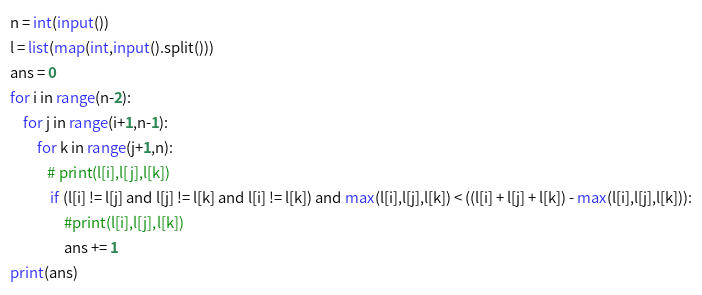<code> <loc_0><loc_0><loc_500><loc_500><_Python_>n = int(input())
l = list(map(int,input().split()))
ans = 0
for i in range(n-2):
    for j in range(i+1,n-1):
        for k in range(j+1,n):
           # print(l[i],l[j],l[k])
            if (l[i] != l[j] and l[j] != l[k] and l[i] != l[k]) and max(l[i],l[j],l[k]) < ((l[i] + l[j] + l[k]) - max(l[i],l[j],l[k])):
                #print(l[i],l[j],l[k])
                ans += 1
print(ans)</code> 